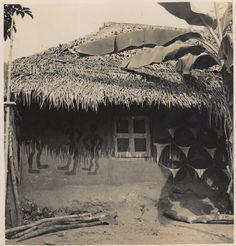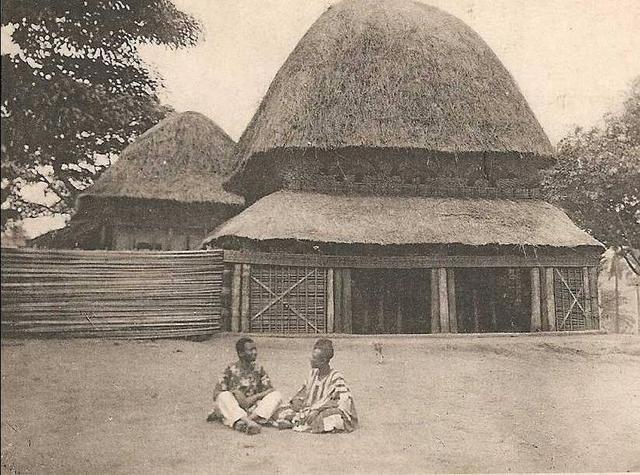The first image is the image on the left, the second image is the image on the right. For the images displayed, is the sentence "There are people in front of a building." factually correct? Answer yes or no. Yes. 